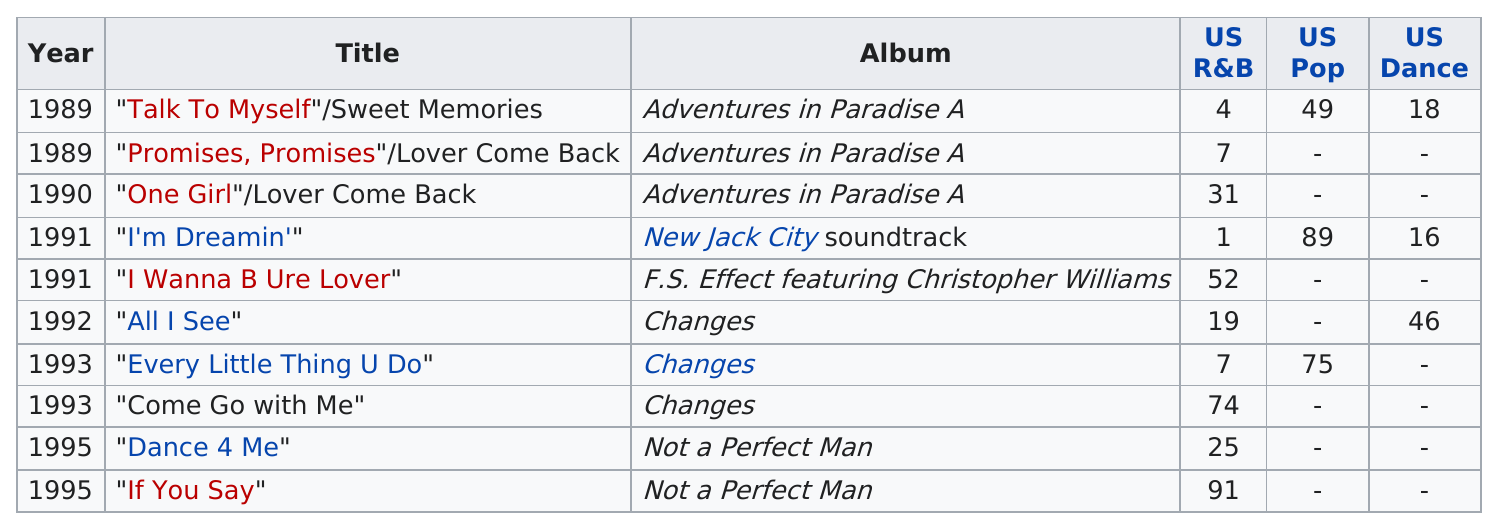Point out several critical features in this image. What is the total number of albums listed? It is 5.. The album "Changes" did not make it on the US dance list in the years 1993. Christopher Williams has 6 songs that ranked in the top 25 on the US R&B charts. Christopher Williams had a song in the top 25 of any chart in the year 1995. Out of the songs recorded by Christopher Williams, how many have appeared on at least two of the three charts? 